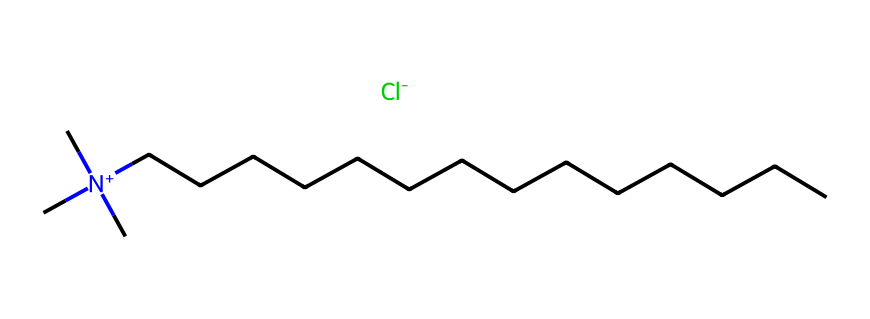What is the primary type of nitrogen in this compound? The nitrogen in this chemical is quaternary because it is connected to four carbon groups, making it positively charged and acting as a quaternary ammonium compound.
Answer: quaternary How many carbon atoms are in this molecule? By analyzing the structure, we see three carbon groups (C) attached to the nitrogen and a long hydrocarbon chain (CCCCCCCCCCCCCC) consisting of 14 carbon atoms. Thus, there are a total of 17 carbon atoms.
Answer: 17 What type of bonding is primarily present in this structure? The compound exhibits covalent bonding as indicated by the connections between carbon and nitrogen atoms, where electrons are shared.
Answer: covalent What is the role of the chloride ion in this compound? The chloride ion (Cl-) acts as the counterion to balance the positive charge of the nitrogen atom, which is crucial for the stability of the quaternary ammonium compound.
Answer: counterion Is this compound typically used for disinfecting horse stalls? Yes, quaternary ammonium compounds are known for their disinfectant properties and are commonly used in veterinary and agricultural settings for sanitation.
Answer: yes What characteristic of the long carbon chain contributes to the detergent properties? The long carbon chain increases hydrophobicity, which enhances the surfactant characteristics of the compound, making it effective in breaking down oils and organic matter.
Answer: hydrophobicity 